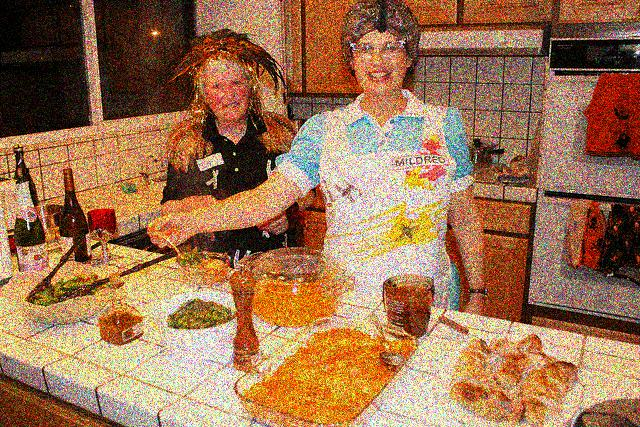Do the two women appear blurry? A. Yes, the image shows two women that appear blurry due to the image quality or an artistic filter that leads to a loss of sharp definition and detail. 